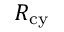<formula> <loc_0><loc_0><loc_500><loc_500>R _ { c y }</formula> 